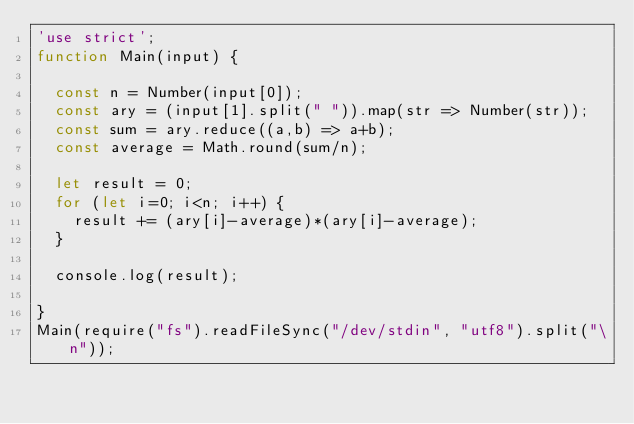<code> <loc_0><loc_0><loc_500><loc_500><_JavaScript_>'use strict';
function Main(input) {

  const n = Number(input[0]);
  const ary = (input[1].split(" ")).map(str => Number(str));
  const sum = ary.reduce((a,b) => a+b);
  const average = Math.round(sum/n);

  let result = 0;
  for (let i=0; i<n; i++) {
    result += (ary[i]-average)*(ary[i]-average);
  }

  console.log(result);

}
Main(require("fs").readFileSync("/dev/stdin", "utf8").split("\n"));
</code> 